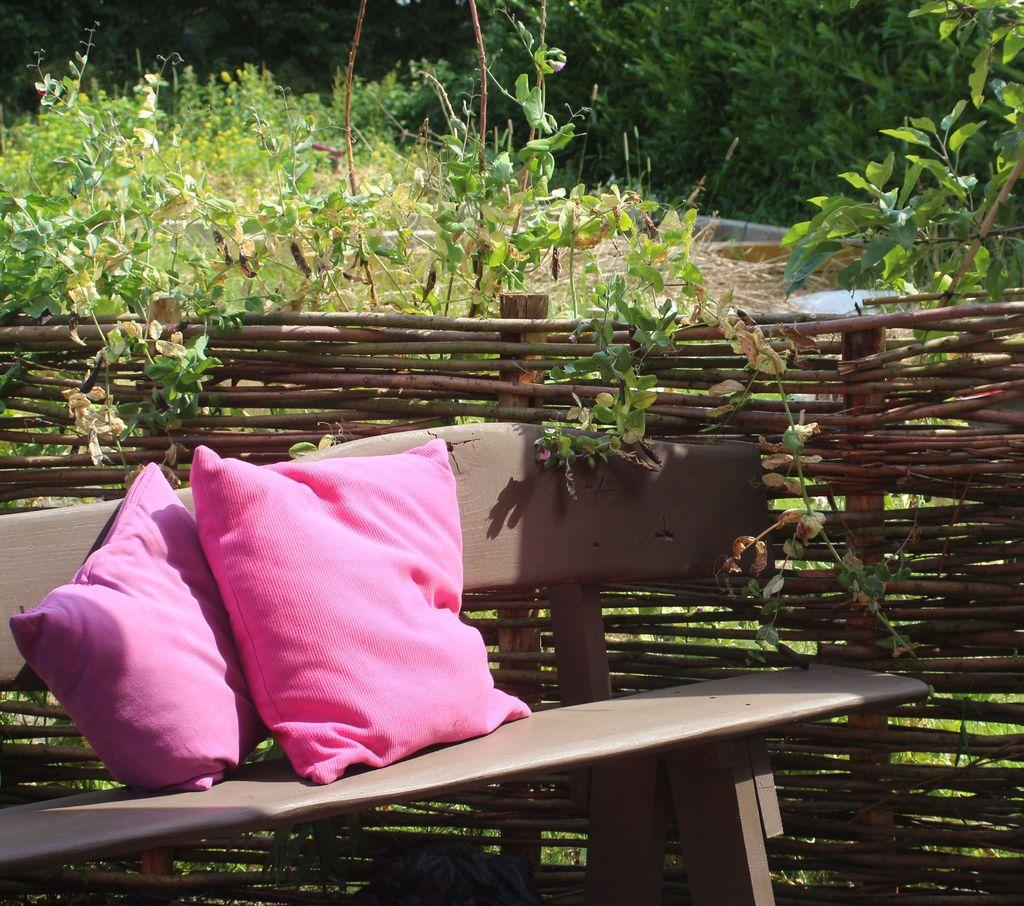What can be seen in the foreground of the picture? In the foreground of the picture, there are plants, a bench, pillows, and wooden fencing. What type of vegetation is visible in the background of the picture? In the background of the picture, there are trees and grass. How many cats are sitting on the bench in the picture? There are no cats present in the picture; the image only features plants, a bench, pillows, and wooden fencing in the foreground, as well as trees and grass in the background. 